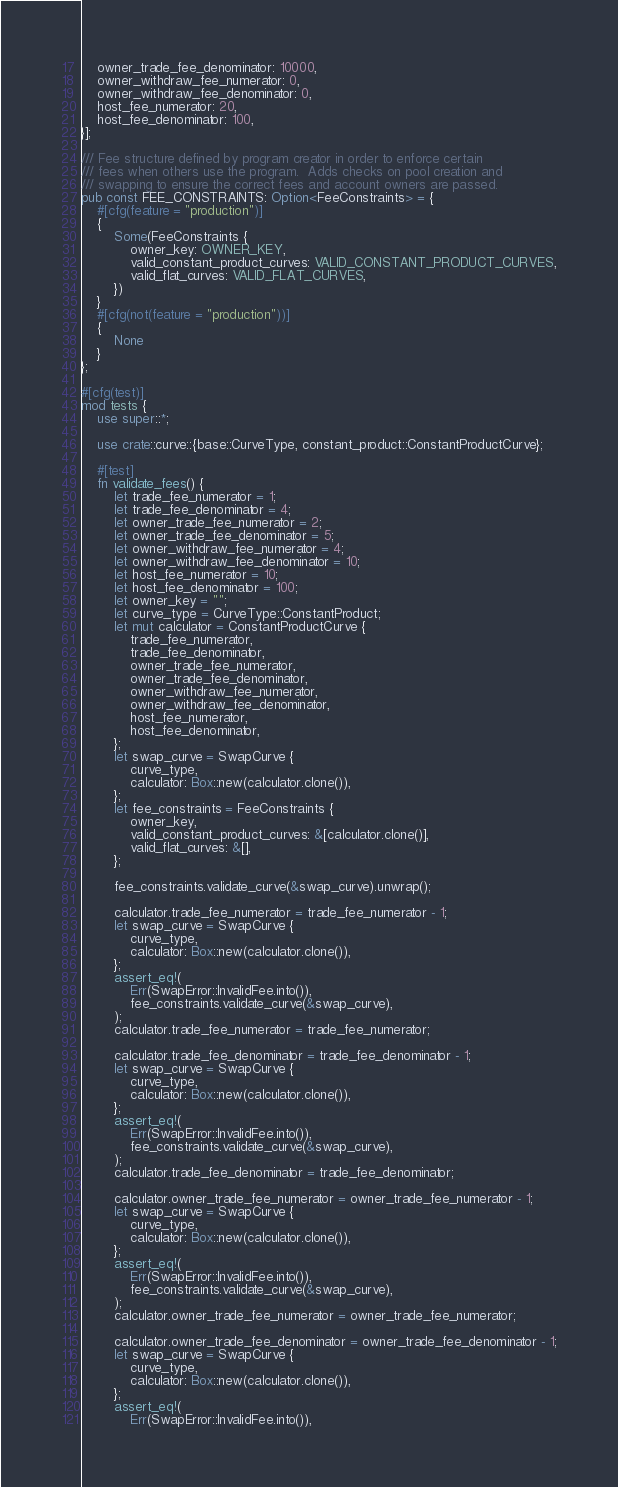Convert code to text. <code><loc_0><loc_0><loc_500><loc_500><_Rust_>    owner_trade_fee_denominator: 10000,
    owner_withdraw_fee_numerator: 0,
    owner_withdraw_fee_denominator: 0,
    host_fee_numerator: 20,
    host_fee_denominator: 100,
}];

/// Fee structure defined by program creator in order to enforce certain
/// fees when others use the program.  Adds checks on pool creation and
/// swapping to ensure the correct fees and account owners are passed.
pub const FEE_CONSTRAINTS: Option<FeeConstraints> = {
    #[cfg(feature = "production")]
    {
        Some(FeeConstraints {
            owner_key: OWNER_KEY,
            valid_constant_product_curves: VALID_CONSTANT_PRODUCT_CURVES,
            valid_flat_curves: VALID_FLAT_CURVES,
        })
    }
    #[cfg(not(feature = "production"))]
    {
        None
    }
};

#[cfg(test)]
mod tests {
    use super::*;

    use crate::curve::{base::CurveType, constant_product::ConstantProductCurve};

    #[test]
    fn validate_fees() {
        let trade_fee_numerator = 1;
        let trade_fee_denominator = 4;
        let owner_trade_fee_numerator = 2;
        let owner_trade_fee_denominator = 5;
        let owner_withdraw_fee_numerator = 4;
        let owner_withdraw_fee_denominator = 10;
        let host_fee_numerator = 10;
        let host_fee_denominator = 100;
        let owner_key = "";
        let curve_type = CurveType::ConstantProduct;
        let mut calculator = ConstantProductCurve {
            trade_fee_numerator,
            trade_fee_denominator,
            owner_trade_fee_numerator,
            owner_trade_fee_denominator,
            owner_withdraw_fee_numerator,
            owner_withdraw_fee_denominator,
            host_fee_numerator,
            host_fee_denominator,
        };
        let swap_curve = SwapCurve {
            curve_type,
            calculator: Box::new(calculator.clone()),
        };
        let fee_constraints = FeeConstraints {
            owner_key,
            valid_constant_product_curves: &[calculator.clone()],
            valid_flat_curves: &[],
        };

        fee_constraints.validate_curve(&swap_curve).unwrap();

        calculator.trade_fee_numerator = trade_fee_numerator - 1;
        let swap_curve = SwapCurve {
            curve_type,
            calculator: Box::new(calculator.clone()),
        };
        assert_eq!(
            Err(SwapError::InvalidFee.into()),
            fee_constraints.validate_curve(&swap_curve),
        );
        calculator.trade_fee_numerator = trade_fee_numerator;

        calculator.trade_fee_denominator = trade_fee_denominator - 1;
        let swap_curve = SwapCurve {
            curve_type,
            calculator: Box::new(calculator.clone()),
        };
        assert_eq!(
            Err(SwapError::InvalidFee.into()),
            fee_constraints.validate_curve(&swap_curve),
        );
        calculator.trade_fee_denominator = trade_fee_denominator;

        calculator.owner_trade_fee_numerator = owner_trade_fee_numerator - 1;
        let swap_curve = SwapCurve {
            curve_type,
            calculator: Box::new(calculator.clone()),
        };
        assert_eq!(
            Err(SwapError::InvalidFee.into()),
            fee_constraints.validate_curve(&swap_curve),
        );
        calculator.owner_trade_fee_numerator = owner_trade_fee_numerator;

        calculator.owner_trade_fee_denominator = owner_trade_fee_denominator - 1;
        let swap_curve = SwapCurve {
            curve_type,
            calculator: Box::new(calculator.clone()),
        };
        assert_eq!(
            Err(SwapError::InvalidFee.into()),</code> 